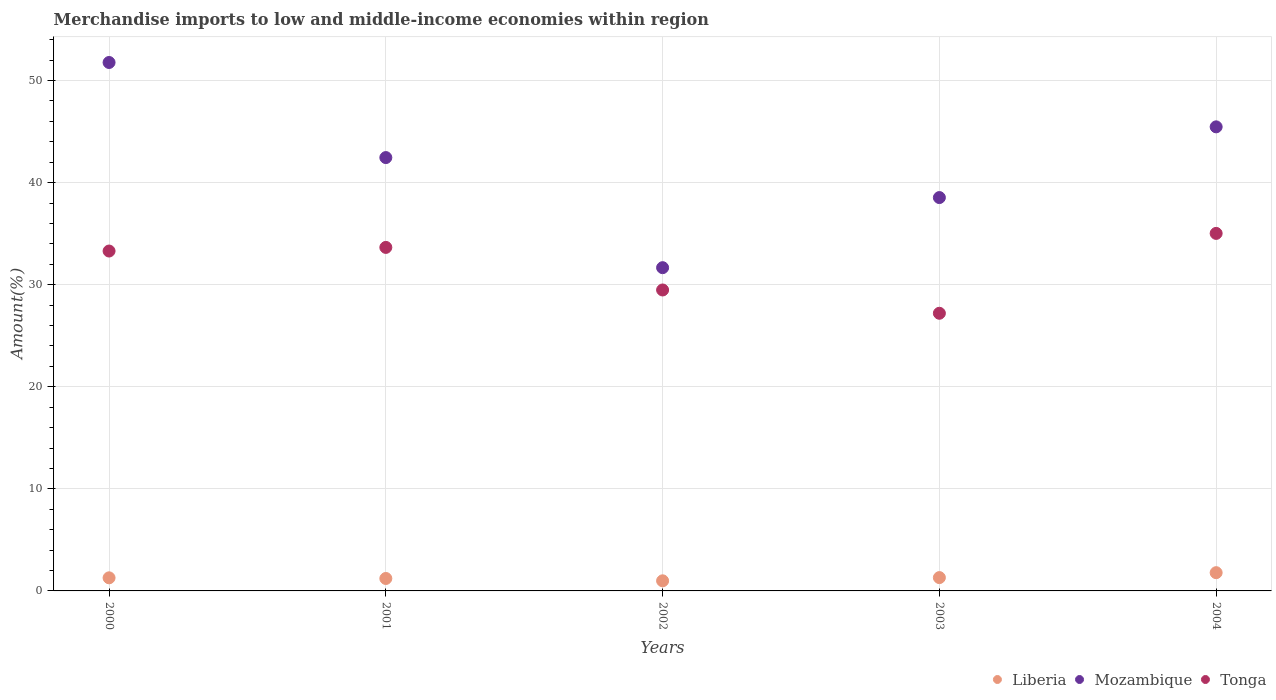How many different coloured dotlines are there?
Your answer should be very brief. 3. What is the percentage of amount earned from merchandise imports in Liberia in 2003?
Provide a succinct answer. 1.3. Across all years, what is the maximum percentage of amount earned from merchandise imports in Mozambique?
Ensure brevity in your answer.  51.77. Across all years, what is the minimum percentage of amount earned from merchandise imports in Tonga?
Offer a terse response. 27.2. In which year was the percentage of amount earned from merchandise imports in Liberia maximum?
Provide a succinct answer. 2004. What is the total percentage of amount earned from merchandise imports in Mozambique in the graph?
Keep it short and to the point. 209.9. What is the difference between the percentage of amount earned from merchandise imports in Liberia in 2000 and that in 2001?
Keep it short and to the point. 0.06. What is the difference between the percentage of amount earned from merchandise imports in Liberia in 2002 and the percentage of amount earned from merchandise imports in Tonga in 2003?
Your answer should be very brief. -26.21. What is the average percentage of amount earned from merchandise imports in Liberia per year?
Give a very brief answer. 1.32. In the year 2003, what is the difference between the percentage of amount earned from merchandise imports in Liberia and percentage of amount earned from merchandise imports in Tonga?
Make the answer very short. -25.9. What is the ratio of the percentage of amount earned from merchandise imports in Mozambique in 2003 to that in 2004?
Make the answer very short. 0.85. Is the difference between the percentage of amount earned from merchandise imports in Liberia in 2000 and 2001 greater than the difference between the percentage of amount earned from merchandise imports in Tonga in 2000 and 2001?
Offer a very short reply. Yes. What is the difference between the highest and the second highest percentage of amount earned from merchandise imports in Tonga?
Provide a short and direct response. 1.37. What is the difference between the highest and the lowest percentage of amount earned from merchandise imports in Liberia?
Offer a terse response. 0.8. In how many years, is the percentage of amount earned from merchandise imports in Mozambique greater than the average percentage of amount earned from merchandise imports in Mozambique taken over all years?
Give a very brief answer. 3. Is it the case that in every year, the sum of the percentage of amount earned from merchandise imports in Mozambique and percentage of amount earned from merchandise imports in Liberia  is greater than the percentage of amount earned from merchandise imports in Tonga?
Offer a terse response. Yes. Is the percentage of amount earned from merchandise imports in Mozambique strictly greater than the percentage of amount earned from merchandise imports in Tonga over the years?
Give a very brief answer. Yes. How many dotlines are there?
Provide a short and direct response. 3. How many years are there in the graph?
Ensure brevity in your answer.  5. What is the difference between two consecutive major ticks on the Y-axis?
Your answer should be very brief. 10. Does the graph contain any zero values?
Offer a terse response. No. How many legend labels are there?
Ensure brevity in your answer.  3. How are the legend labels stacked?
Your answer should be compact. Horizontal. What is the title of the graph?
Offer a very short reply. Merchandise imports to low and middle-income economies within region. What is the label or title of the Y-axis?
Make the answer very short. Amount(%). What is the Amount(%) of Liberia in 2000?
Provide a succinct answer. 1.28. What is the Amount(%) of Mozambique in 2000?
Make the answer very short. 51.77. What is the Amount(%) of Tonga in 2000?
Ensure brevity in your answer.  33.3. What is the Amount(%) of Liberia in 2001?
Keep it short and to the point. 1.22. What is the Amount(%) in Mozambique in 2001?
Provide a short and direct response. 42.46. What is the Amount(%) in Tonga in 2001?
Your answer should be very brief. 33.66. What is the Amount(%) in Liberia in 2002?
Your answer should be very brief. 0.99. What is the Amount(%) in Mozambique in 2002?
Provide a succinct answer. 31.67. What is the Amount(%) in Tonga in 2002?
Offer a very short reply. 29.48. What is the Amount(%) in Liberia in 2003?
Your answer should be very brief. 1.3. What is the Amount(%) of Mozambique in 2003?
Ensure brevity in your answer.  38.54. What is the Amount(%) of Tonga in 2003?
Ensure brevity in your answer.  27.2. What is the Amount(%) in Liberia in 2004?
Your answer should be compact. 1.79. What is the Amount(%) in Mozambique in 2004?
Your response must be concise. 45.47. What is the Amount(%) of Tonga in 2004?
Your response must be concise. 35.03. Across all years, what is the maximum Amount(%) in Liberia?
Make the answer very short. 1.79. Across all years, what is the maximum Amount(%) of Mozambique?
Offer a very short reply. 51.77. Across all years, what is the maximum Amount(%) in Tonga?
Your answer should be compact. 35.03. Across all years, what is the minimum Amount(%) in Liberia?
Keep it short and to the point. 0.99. Across all years, what is the minimum Amount(%) in Mozambique?
Provide a succinct answer. 31.67. Across all years, what is the minimum Amount(%) of Tonga?
Your response must be concise. 27.2. What is the total Amount(%) of Liberia in the graph?
Your response must be concise. 6.59. What is the total Amount(%) of Mozambique in the graph?
Offer a terse response. 209.9. What is the total Amount(%) in Tonga in the graph?
Your answer should be compact. 158.67. What is the difference between the Amount(%) of Liberia in 2000 and that in 2001?
Offer a very short reply. 0.06. What is the difference between the Amount(%) in Mozambique in 2000 and that in 2001?
Give a very brief answer. 9.32. What is the difference between the Amount(%) in Tonga in 2000 and that in 2001?
Provide a short and direct response. -0.36. What is the difference between the Amount(%) in Liberia in 2000 and that in 2002?
Provide a succinct answer. 0.29. What is the difference between the Amount(%) of Mozambique in 2000 and that in 2002?
Your answer should be compact. 20.1. What is the difference between the Amount(%) in Tonga in 2000 and that in 2002?
Give a very brief answer. 3.82. What is the difference between the Amount(%) in Liberia in 2000 and that in 2003?
Your response must be concise. -0.02. What is the difference between the Amount(%) in Mozambique in 2000 and that in 2003?
Ensure brevity in your answer.  13.23. What is the difference between the Amount(%) of Tonga in 2000 and that in 2003?
Ensure brevity in your answer.  6.1. What is the difference between the Amount(%) in Liberia in 2000 and that in 2004?
Make the answer very short. -0.5. What is the difference between the Amount(%) of Mozambique in 2000 and that in 2004?
Make the answer very short. 6.31. What is the difference between the Amount(%) of Tonga in 2000 and that in 2004?
Offer a very short reply. -1.73. What is the difference between the Amount(%) in Liberia in 2001 and that in 2002?
Ensure brevity in your answer.  0.23. What is the difference between the Amount(%) in Mozambique in 2001 and that in 2002?
Provide a succinct answer. 10.79. What is the difference between the Amount(%) in Tonga in 2001 and that in 2002?
Give a very brief answer. 4.17. What is the difference between the Amount(%) of Liberia in 2001 and that in 2003?
Your answer should be very brief. -0.09. What is the difference between the Amount(%) of Mozambique in 2001 and that in 2003?
Provide a short and direct response. 3.92. What is the difference between the Amount(%) in Tonga in 2001 and that in 2003?
Your response must be concise. 6.45. What is the difference between the Amount(%) of Liberia in 2001 and that in 2004?
Offer a very short reply. -0.57. What is the difference between the Amount(%) of Mozambique in 2001 and that in 2004?
Your response must be concise. -3.01. What is the difference between the Amount(%) of Tonga in 2001 and that in 2004?
Your response must be concise. -1.37. What is the difference between the Amount(%) of Liberia in 2002 and that in 2003?
Provide a short and direct response. -0.31. What is the difference between the Amount(%) in Mozambique in 2002 and that in 2003?
Ensure brevity in your answer.  -6.87. What is the difference between the Amount(%) in Tonga in 2002 and that in 2003?
Your answer should be very brief. 2.28. What is the difference between the Amount(%) in Liberia in 2002 and that in 2004?
Your answer should be compact. -0.8. What is the difference between the Amount(%) of Mozambique in 2002 and that in 2004?
Give a very brief answer. -13.8. What is the difference between the Amount(%) of Tonga in 2002 and that in 2004?
Your answer should be very brief. -5.54. What is the difference between the Amount(%) in Liberia in 2003 and that in 2004?
Keep it short and to the point. -0.48. What is the difference between the Amount(%) in Mozambique in 2003 and that in 2004?
Offer a terse response. -6.93. What is the difference between the Amount(%) in Tonga in 2003 and that in 2004?
Offer a very short reply. -7.82. What is the difference between the Amount(%) of Liberia in 2000 and the Amount(%) of Mozambique in 2001?
Make the answer very short. -41.17. What is the difference between the Amount(%) in Liberia in 2000 and the Amount(%) in Tonga in 2001?
Your response must be concise. -32.37. What is the difference between the Amount(%) in Mozambique in 2000 and the Amount(%) in Tonga in 2001?
Give a very brief answer. 18.12. What is the difference between the Amount(%) in Liberia in 2000 and the Amount(%) in Mozambique in 2002?
Make the answer very short. -30.39. What is the difference between the Amount(%) of Liberia in 2000 and the Amount(%) of Tonga in 2002?
Provide a succinct answer. -28.2. What is the difference between the Amount(%) in Mozambique in 2000 and the Amount(%) in Tonga in 2002?
Keep it short and to the point. 22.29. What is the difference between the Amount(%) in Liberia in 2000 and the Amount(%) in Mozambique in 2003?
Make the answer very short. -37.25. What is the difference between the Amount(%) in Liberia in 2000 and the Amount(%) in Tonga in 2003?
Offer a terse response. -25.92. What is the difference between the Amount(%) of Mozambique in 2000 and the Amount(%) of Tonga in 2003?
Provide a succinct answer. 24.57. What is the difference between the Amount(%) in Liberia in 2000 and the Amount(%) in Mozambique in 2004?
Your answer should be very brief. -44.18. What is the difference between the Amount(%) of Liberia in 2000 and the Amount(%) of Tonga in 2004?
Your response must be concise. -33.74. What is the difference between the Amount(%) in Mozambique in 2000 and the Amount(%) in Tonga in 2004?
Offer a very short reply. 16.74. What is the difference between the Amount(%) in Liberia in 2001 and the Amount(%) in Mozambique in 2002?
Provide a succinct answer. -30.45. What is the difference between the Amount(%) in Liberia in 2001 and the Amount(%) in Tonga in 2002?
Offer a very short reply. -28.26. What is the difference between the Amount(%) in Mozambique in 2001 and the Amount(%) in Tonga in 2002?
Provide a succinct answer. 12.97. What is the difference between the Amount(%) in Liberia in 2001 and the Amount(%) in Mozambique in 2003?
Offer a very short reply. -37.32. What is the difference between the Amount(%) in Liberia in 2001 and the Amount(%) in Tonga in 2003?
Your response must be concise. -25.98. What is the difference between the Amount(%) in Mozambique in 2001 and the Amount(%) in Tonga in 2003?
Keep it short and to the point. 15.25. What is the difference between the Amount(%) of Liberia in 2001 and the Amount(%) of Mozambique in 2004?
Make the answer very short. -44.25. What is the difference between the Amount(%) in Liberia in 2001 and the Amount(%) in Tonga in 2004?
Give a very brief answer. -33.81. What is the difference between the Amount(%) of Mozambique in 2001 and the Amount(%) of Tonga in 2004?
Offer a terse response. 7.43. What is the difference between the Amount(%) in Liberia in 2002 and the Amount(%) in Mozambique in 2003?
Your answer should be very brief. -37.55. What is the difference between the Amount(%) in Liberia in 2002 and the Amount(%) in Tonga in 2003?
Offer a terse response. -26.21. What is the difference between the Amount(%) of Mozambique in 2002 and the Amount(%) of Tonga in 2003?
Keep it short and to the point. 4.47. What is the difference between the Amount(%) in Liberia in 2002 and the Amount(%) in Mozambique in 2004?
Provide a short and direct response. -44.48. What is the difference between the Amount(%) in Liberia in 2002 and the Amount(%) in Tonga in 2004?
Offer a terse response. -34.04. What is the difference between the Amount(%) of Mozambique in 2002 and the Amount(%) of Tonga in 2004?
Keep it short and to the point. -3.36. What is the difference between the Amount(%) of Liberia in 2003 and the Amount(%) of Mozambique in 2004?
Provide a short and direct response. -44.16. What is the difference between the Amount(%) of Liberia in 2003 and the Amount(%) of Tonga in 2004?
Your answer should be very brief. -33.72. What is the difference between the Amount(%) in Mozambique in 2003 and the Amount(%) in Tonga in 2004?
Keep it short and to the point. 3.51. What is the average Amount(%) of Liberia per year?
Ensure brevity in your answer.  1.32. What is the average Amount(%) of Mozambique per year?
Ensure brevity in your answer.  41.98. What is the average Amount(%) of Tonga per year?
Ensure brevity in your answer.  31.73. In the year 2000, what is the difference between the Amount(%) in Liberia and Amount(%) in Mozambique?
Your response must be concise. -50.49. In the year 2000, what is the difference between the Amount(%) of Liberia and Amount(%) of Tonga?
Make the answer very short. -32.02. In the year 2000, what is the difference between the Amount(%) in Mozambique and Amount(%) in Tonga?
Ensure brevity in your answer.  18.47. In the year 2001, what is the difference between the Amount(%) in Liberia and Amount(%) in Mozambique?
Ensure brevity in your answer.  -41.24. In the year 2001, what is the difference between the Amount(%) of Liberia and Amount(%) of Tonga?
Keep it short and to the point. -32.44. In the year 2001, what is the difference between the Amount(%) of Mozambique and Amount(%) of Tonga?
Your answer should be compact. 8.8. In the year 2002, what is the difference between the Amount(%) of Liberia and Amount(%) of Mozambique?
Your response must be concise. -30.68. In the year 2002, what is the difference between the Amount(%) of Liberia and Amount(%) of Tonga?
Provide a succinct answer. -28.49. In the year 2002, what is the difference between the Amount(%) of Mozambique and Amount(%) of Tonga?
Your answer should be compact. 2.19. In the year 2003, what is the difference between the Amount(%) of Liberia and Amount(%) of Mozambique?
Keep it short and to the point. -37.23. In the year 2003, what is the difference between the Amount(%) in Liberia and Amount(%) in Tonga?
Provide a short and direct response. -25.9. In the year 2003, what is the difference between the Amount(%) of Mozambique and Amount(%) of Tonga?
Ensure brevity in your answer.  11.33. In the year 2004, what is the difference between the Amount(%) in Liberia and Amount(%) in Mozambique?
Keep it short and to the point. -43.68. In the year 2004, what is the difference between the Amount(%) in Liberia and Amount(%) in Tonga?
Offer a terse response. -33.24. In the year 2004, what is the difference between the Amount(%) of Mozambique and Amount(%) of Tonga?
Offer a terse response. 10.44. What is the ratio of the Amount(%) in Liberia in 2000 to that in 2001?
Offer a terse response. 1.05. What is the ratio of the Amount(%) in Mozambique in 2000 to that in 2001?
Make the answer very short. 1.22. What is the ratio of the Amount(%) in Tonga in 2000 to that in 2001?
Your response must be concise. 0.99. What is the ratio of the Amount(%) of Liberia in 2000 to that in 2002?
Your response must be concise. 1.3. What is the ratio of the Amount(%) in Mozambique in 2000 to that in 2002?
Offer a very short reply. 1.63. What is the ratio of the Amount(%) of Tonga in 2000 to that in 2002?
Provide a short and direct response. 1.13. What is the ratio of the Amount(%) in Liberia in 2000 to that in 2003?
Your answer should be compact. 0.98. What is the ratio of the Amount(%) in Mozambique in 2000 to that in 2003?
Offer a terse response. 1.34. What is the ratio of the Amount(%) in Tonga in 2000 to that in 2003?
Your answer should be very brief. 1.22. What is the ratio of the Amount(%) of Liberia in 2000 to that in 2004?
Your response must be concise. 0.72. What is the ratio of the Amount(%) in Mozambique in 2000 to that in 2004?
Keep it short and to the point. 1.14. What is the ratio of the Amount(%) of Tonga in 2000 to that in 2004?
Provide a succinct answer. 0.95. What is the ratio of the Amount(%) in Liberia in 2001 to that in 2002?
Make the answer very short. 1.23. What is the ratio of the Amount(%) in Mozambique in 2001 to that in 2002?
Offer a very short reply. 1.34. What is the ratio of the Amount(%) in Tonga in 2001 to that in 2002?
Your answer should be very brief. 1.14. What is the ratio of the Amount(%) in Liberia in 2001 to that in 2003?
Offer a very short reply. 0.93. What is the ratio of the Amount(%) of Mozambique in 2001 to that in 2003?
Keep it short and to the point. 1.1. What is the ratio of the Amount(%) in Tonga in 2001 to that in 2003?
Provide a short and direct response. 1.24. What is the ratio of the Amount(%) of Liberia in 2001 to that in 2004?
Provide a short and direct response. 0.68. What is the ratio of the Amount(%) in Mozambique in 2001 to that in 2004?
Your answer should be very brief. 0.93. What is the ratio of the Amount(%) of Tonga in 2001 to that in 2004?
Your answer should be very brief. 0.96. What is the ratio of the Amount(%) in Liberia in 2002 to that in 2003?
Make the answer very short. 0.76. What is the ratio of the Amount(%) in Mozambique in 2002 to that in 2003?
Provide a short and direct response. 0.82. What is the ratio of the Amount(%) in Tonga in 2002 to that in 2003?
Your answer should be compact. 1.08. What is the ratio of the Amount(%) of Liberia in 2002 to that in 2004?
Provide a short and direct response. 0.55. What is the ratio of the Amount(%) of Mozambique in 2002 to that in 2004?
Keep it short and to the point. 0.7. What is the ratio of the Amount(%) of Tonga in 2002 to that in 2004?
Make the answer very short. 0.84. What is the ratio of the Amount(%) in Liberia in 2003 to that in 2004?
Provide a short and direct response. 0.73. What is the ratio of the Amount(%) of Mozambique in 2003 to that in 2004?
Your response must be concise. 0.85. What is the ratio of the Amount(%) in Tonga in 2003 to that in 2004?
Provide a succinct answer. 0.78. What is the difference between the highest and the second highest Amount(%) of Liberia?
Provide a short and direct response. 0.48. What is the difference between the highest and the second highest Amount(%) in Mozambique?
Your response must be concise. 6.31. What is the difference between the highest and the second highest Amount(%) of Tonga?
Your response must be concise. 1.37. What is the difference between the highest and the lowest Amount(%) of Liberia?
Provide a succinct answer. 0.8. What is the difference between the highest and the lowest Amount(%) in Mozambique?
Your answer should be very brief. 20.1. What is the difference between the highest and the lowest Amount(%) of Tonga?
Offer a terse response. 7.82. 